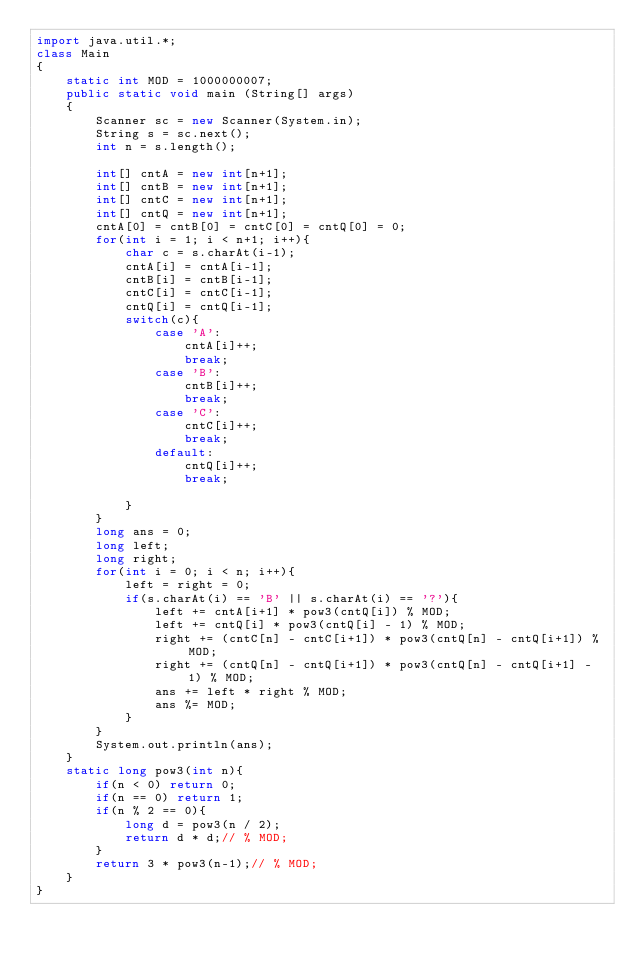<code> <loc_0><loc_0><loc_500><loc_500><_Java_>import java.util.*;
class Main
{
    static int MOD = 1000000007;
    public static void main (String[] args)
    {
        Scanner sc = new Scanner(System.in);
        String s = sc.next();
        int n = s.length();

        int[] cntA = new int[n+1];
        int[] cntB = new int[n+1];
        int[] cntC = new int[n+1];
        int[] cntQ = new int[n+1];
        cntA[0] = cntB[0] = cntC[0] = cntQ[0] = 0;
        for(int i = 1; i < n+1; i++){
            char c = s.charAt(i-1);
            cntA[i] = cntA[i-1];
            cntB[i] = cntB[i-1];
            cntC[i] = cntC[i-1]; 
            cntQ[i] = cntQ[i-1];           
            switch(c){
                case 'A':
                    cntA[i]++;
                    break;
                case 'B':
                    cntB[i]++;
                    break;
                case 'C':
                    cntC[i]++;
                    break;
                default:
                    cntQ[i]++;
                    break;

            }
        }
        long ans = 0;
        long left;
        long right;
        for(int i = 0; i < n; i++){
            left = right = 0;
            if(s.charAt(i) == 'B' || s.charAt(i) == '?'){
                left += cntA[i+1] * pow3(cntQ[i]) % MOD;
                left += cntQ[i] * pow3(cntQ[i] - 1) % MOD;
                right += (cntC[n] - cntC[i+1]) * pow3(cntQ[n] - cntQ[i+1]) % MOD;
                right += (cntQ[n] - cntQ[i+1]) * pow3(cntQ[n] - cntQ[i+1] - 1) % MOD;
                ans += left * right % MOD;
                ans %= MOD;
            }
        }
        System.out.println(ans);
    }
    static long pow3(int n){
        if(n < 0) return 0;
        if(n == 0) return 1;
        if(n % 2 == 0){
            long d = pow3(n / 2);
            return d * d;// % MOD;
        }
        return 3 * pow3(n-1);// % MOD;
    }
}</code> 